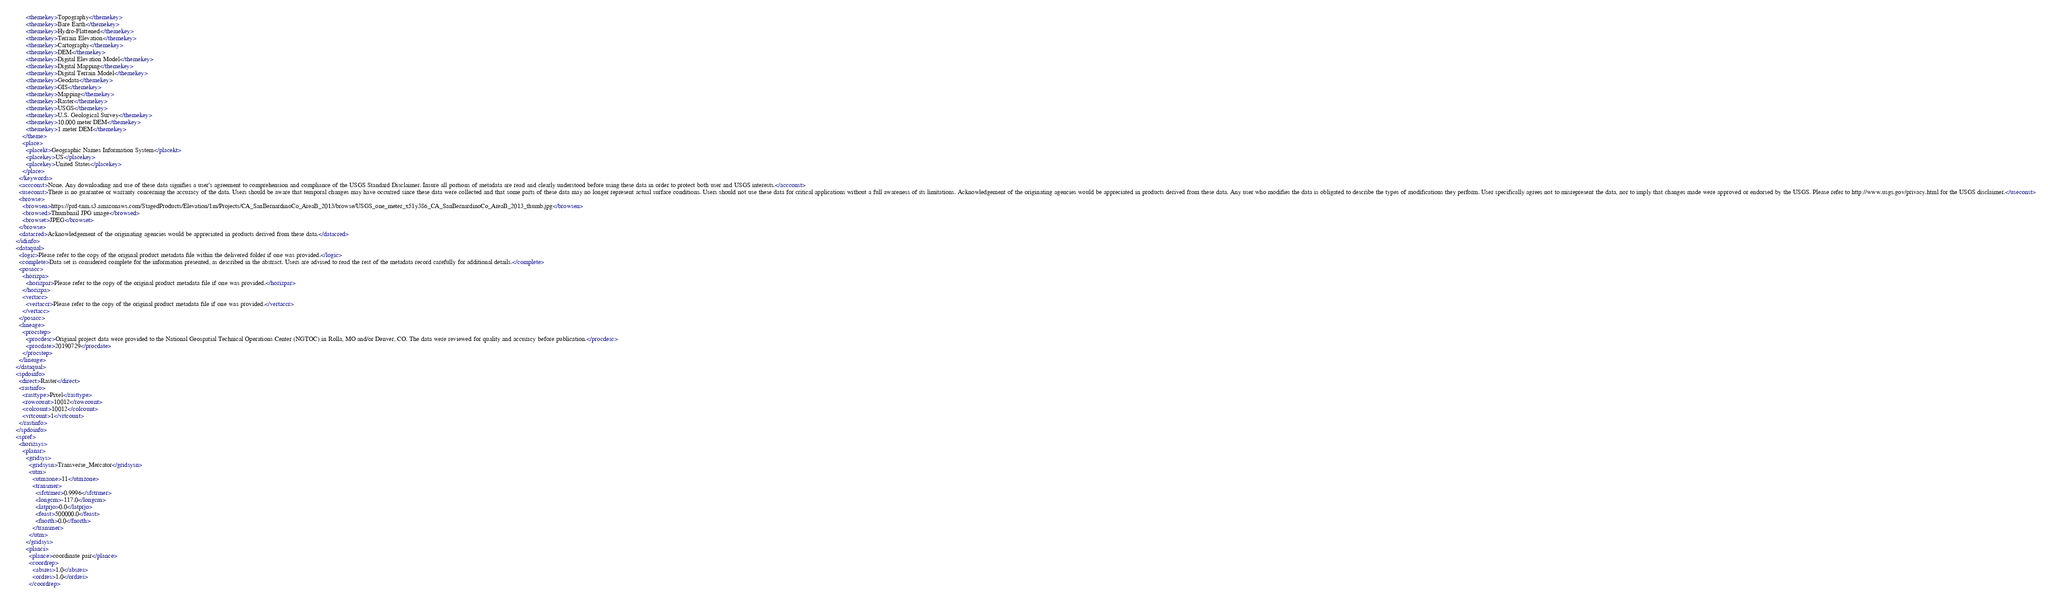<code> <loc_0><loc_0><loc_500><loc_500><_XML_>        <themekey>Topography</themekey>
        <themekey>Bare Earth</themekey>
        <themekey>Hydro-Flattened</themekey>
        <themekey>Terrain Elevation</themekey>
        <themekey>Cartography</themekey>
        <themekey>DEM</themekey>
        <themekey>Digital Elevation Model</themekey>
        <themekey>Digital Mapping</themekey>
        <themekey>Digital Terrain Model</themekey>
        <themekey>Geodata</themekey>
        <themekey>GIS</themekey>
        <themekey>Mapping</themekey>
        <themekey>Raster</themekey>
        <themekey>USGS</themekey>
        <themekey>U.S. Geological Survey</themekey>
        <themekey>10,000 meter DEM</themekey>
        <themekey>1 meter DEM</themekey>
      </theme>
      <place>
        <placekt>Geographic Names Information System</placekt>
        <placekey>US</placekey>
        <placekey>United States</placekey>
      </place>
    </keywords>
    <accconst>None. Any downloading and use of these data signifies a user's agreement to comprehension and compliance of the USGS Standard Disclaimer. Insure all portions of metadata are read and clearly understood before using these data in order to protect both user and USGS interests.</accconst>
    <useconst>There is no guarantee or warranty concerning the accuracy of the data. Users should be aware that temporal changes may have occurred since these data were collected and that some parts of these data may no longer represent actual surface conditions. Users should not use these data for critical applications without a full awareness of its limitations. Acknowledgement of the originating agencies would be appreciated in products derived from these data. Any user who modifies the data is obligated to describe the types of modifications they perform. User specifically agrees not to misrepresent the data, nor to imply that changes made were approved or endorsed by the USGS. Please refer to http://www.usgs.gov/privacy.html for the USGS disclaimer.</useconst>
    <browse>
      <browsen>https://prd-tnm.s3.amazonaws.com/StagedProducts/Elevation/1m/Projects/CA_SanBernardinoCo_AreaB_2013/browse/USGS_one_meter_x51y386_CA_SanBernardinoCo_AreaB_2013_thumb.jpg</browsen>
      <browsed>Thumbnail JPG image</browsed>
      <browset>JPEG</browset>
    </browse>
    <datacred>Acknowledgement of the originating agencies would be appreciated in products derived from these data.</datacred>
  </idinfo>
  <dataqual>
    <logic>Please refer to the copy of the original product metadata file within the delivered folder if one was provided.</logic>
    <complete>Data set is considered complete for the information presented, as described in the abstract. Users are advised to read the rest of the metadata record carefully for additional details.</complete>
    <posacc>
      <horizpa>
        <horizpar>Please refer to the copy of the original product metadata file if one was provided.</horizpar>
      </horizpa>
      <vertacc>
        <vertaccr>Please refer to the copy of the original product metadata file if one was provided.</vertaccr>
      </vertacc>
    </posacc>
    <lineage>
      <procstep>
        <procdesc>Original project data were provided to the National Geospatial Technical Operations Center (NGTOC) in Rolla, MO and/or Denver, CO. The data were reviewed for quality and accuracy before publication.</procdesc>
        <procdate>20190729</procdate>
      </procstep>
    </lineage>
  </dataqual>
  <spdoinfo>
    <direct>Raster</direct>
    <rastinfo>
      <rasttype>Pixel</rasttype>
      <rowcount>10012</rowcount>
      <colcount>10012</colcount>
      <vrtcount>1</vrtcount>
    </rastinfo>
  </spdoinfo>
  <spref>
    <horizsys>
      <planar>
        <gridsys>
          <gridsysn>Transverse_Mercator</gridsysn>
          <utm>
            <utmzone>11</utmzone>
            <transmer>
              <sfctrmer>0.9996</sfctrmer>
              <longcm>-117.0</longcm>
              <latprjo>0.0</latprjo>
              <feast>500000.0</feast>
              <fnorth>0.0</fnorth>
            </transmer>
          </utm>
        </gridsys>
        <planci>
          <plance>coordinate pair</plance>
          <coordrep>
            <absres>1.0</absres>
            <ordres>1.0</ordres>
          </coordrep></code> 